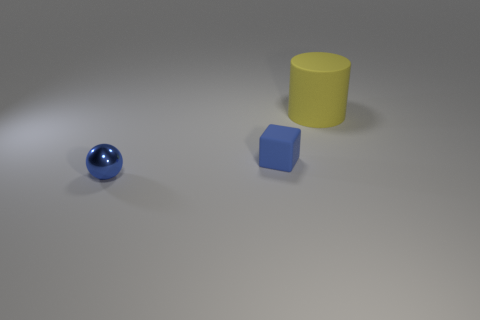What is the size of the rubber thing that is the same color as the shiny thing?
Your answer should be compact. Small. Is the color of the small object on the right side of the blue shiny thing the same as the thing that is in front of the small blue block?
Offer a very short reply. Yes. There is a rubber thing that is to the right of the small rubber object; what is its shape?
Offer a terse response. Cylinder. How many other things are there of the same size as the yellow cylinder?
Offer a terse response. 0. There is a big rubber thing; how many things are to the left of it?
Keep it short and to the point. 2. There is a tiny thing that is behind the small blue sphere; what is its color?
Give a very brief answer. Blue. Is there anything else of the same color as the big cylinder?
Offer a terse response. No. Is the number of tiny blue rubber objects greater than the number of tiny yellow matte blocks?
Your answer should be compact. Yes. Is the material of the tiny block the same as the tiny blue ball?
Offer a terse response. No. What number of tiny blue things have the same material as the yellow object?
Give a very brief answer. 1. 